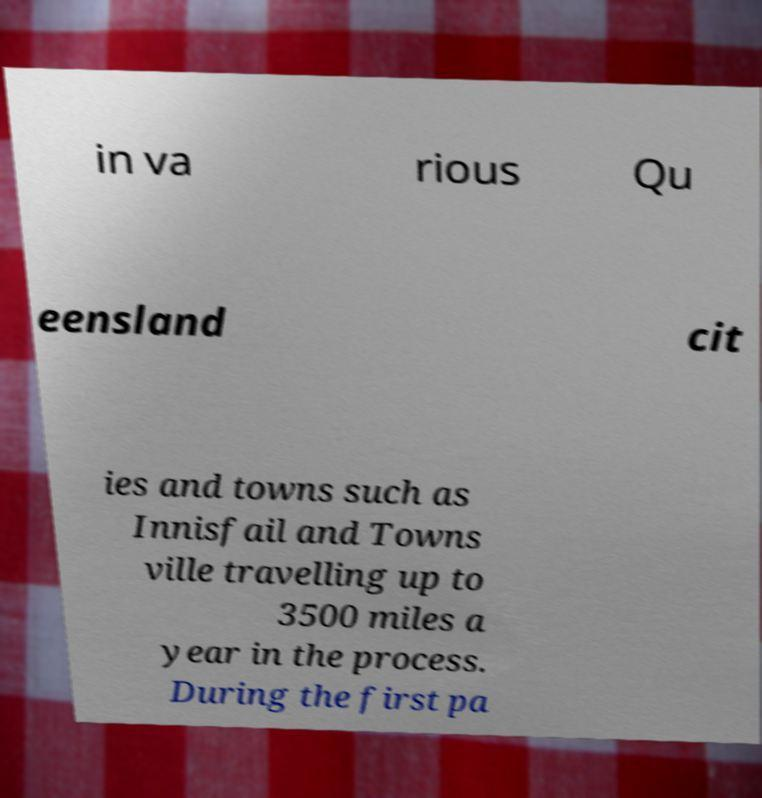Could you extract and type out the text from this image? in va rious Qu eensland cit ies and towns such as Innisfail and Towns ville travelling up to 3500 miles a year in the process. During the first pa 